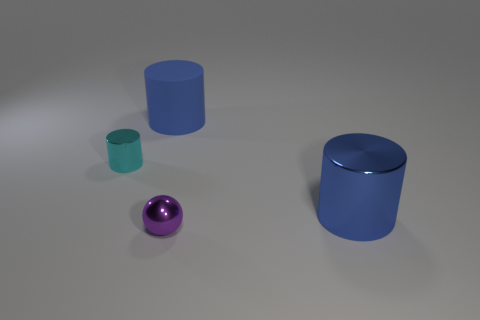Does the purple object have the same shape as the cyan object?
Your answer should be compact. No. Does the small cyan object have the same material as the blue cylinder that is in front of the matte cylinder?
Ensure brevity in your answer.  Yes. What is the big blue thing that is in front of the big blue matte thing made of?
Keep it short and to the point. Metal. What is the size of the cyan shiny thing?
Provide a succinct answer. Small. There is a blue object that is to the left of the small purple metallic thing; is it the same size as the blue cylinder on the right side of the purple ball?
Your answer should be very brief. Yes. What is the size of the other shiny thing that is the same shape as the tiny cyan metallic thing?
Ensure brevity in your answer.  Large. Is the size of the sphere the same as the shiny cylinder that is left of the large blue metal cylinder?
Ensure brevity in your answer.  Yes. Are there any purple things that are on the right side of the big blue object that is in front of the tiny cylinder?
Make the answer very short. No. What is the shape of the tiny metallic object behind the shiny sphere?
Offer a terse response. Cylinder. What is the material of the cylinder that is the same color as the big metal thing?
Your response must be concise. Rubber. 